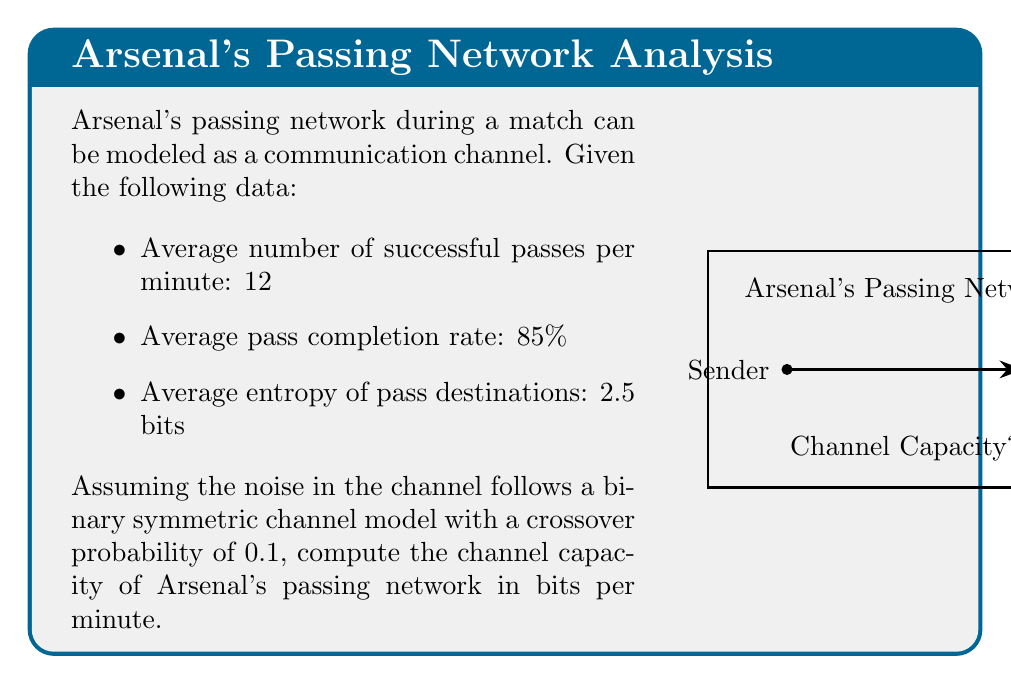Give your solution to this math problem. To solve this problem, we'll follow these steps:

1) First, we need to calculate the mutual information $I(X;Y)$ between the input $X$ and output $Y$ of the channel.

2) The mutual information is given by $I(X;Y) = H(Y) - H(Y|X)$, where $H(Y)$ is the entropy of the output and $H(Y|X)$ is the conditional entropy of the output given the input.

3) We're given that the average entropy of pass destinations is 2.5 bits, so $H(Y) = 2.5$ bits.

4) For a binary symmetric channel with crossover probability $p$, $H(Y|X) = H(p) = -p\log_2(p) - (1-p)\log_2(1-p)$.

5) With $p = 0.1$, we can calculate:
   $H(Y|X) = -0.1\log_2(0.1) - 0.9\log_2(0.9) \approx 0.469$ bits

6) Now we can calculate the mutual information:
   $I(X;Y) = H(Y) - H(Y|X) = 2.5 - 0.469 = 2.031$ bits per pass

7) The channel capacity is the maximum mutual information over all possible input distributions. In this case, we've been given the mutual information for the actual input distribution, which we'll assume is optimal.

8) To get the capacity in bits per minute, we multiply by the number of successful passes per minute:
   $C = 2.031 \times 12 = 24.372$ bits per minute

Therefore, the channel capacity of Arsenal's passing network is approximately 24.372 bits per minute.
Answer: 24.372 bits/minute 